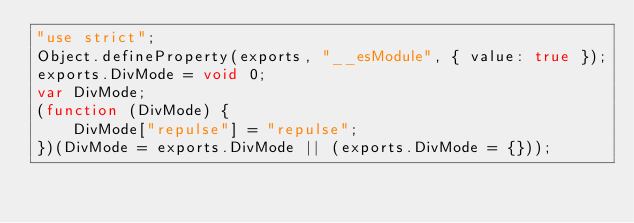Convert code to text. <code><loc_0><loc_0><loc_500><loc_500><_JavaScript_>"use strict";
Object.defineProperty(exports, "__esModule", { value: true });
exports.DivMode = void 0;
var DivMode;
(function (DivMode) {
    DivMode["repulse"] = "repulse";
})(DivMode = exports.DivMode || (exports.DivMode = {}));
</code> 